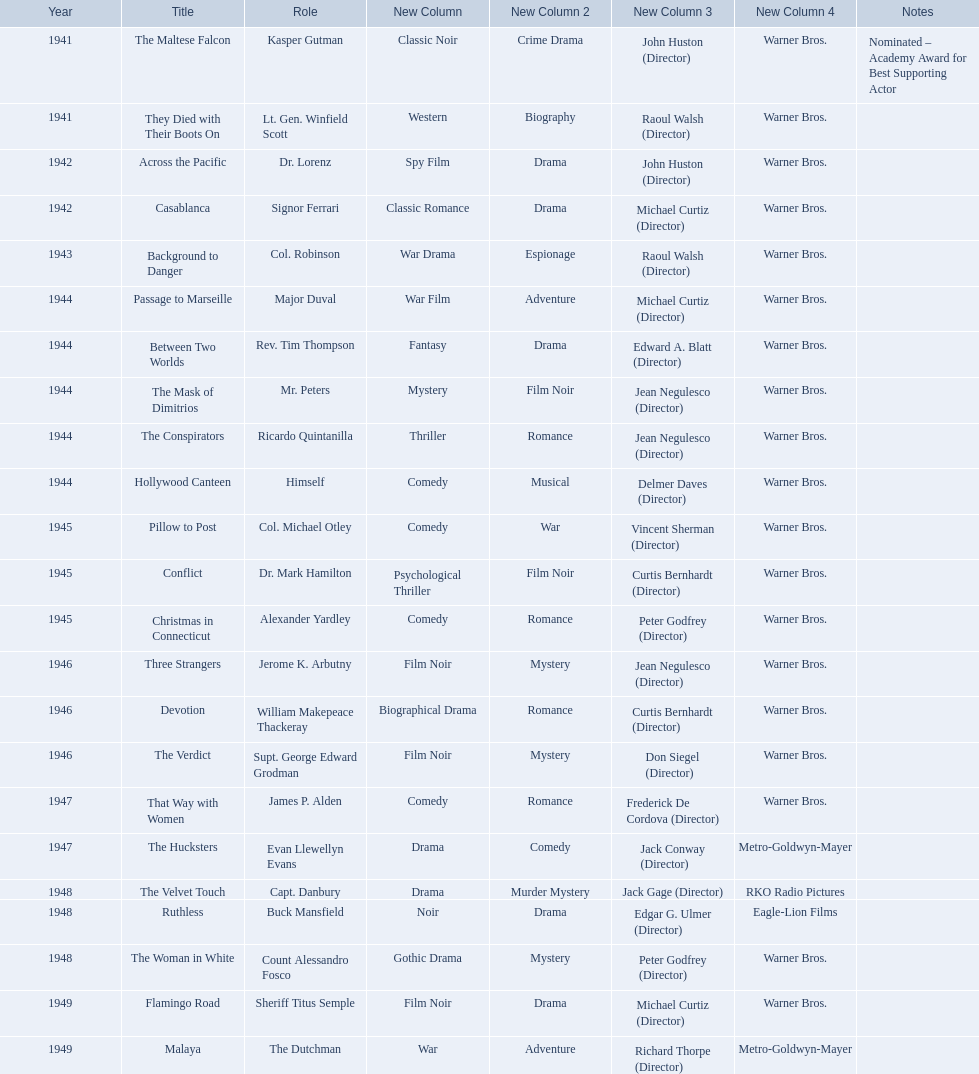What are the movies? The Maltese Falcon, They Died with Their Boots On, Across the Pacific, Casablanca, Background to Danger, Passage to Marseille, Between Two Worlds, The Mask of Dimitrios, The Conspirators, Hollywood Canteen, Pillow to Post, Conflict, Christmas in Connecticut, Three Strangers, Devotion, The Verdict, That Way with Women, The Hucksters, The Velvet Touch, Ruthless, The Woman in White, Flamingo Road, Malaya. Of these, for which did he get nominated for an oscar? The Maltese Falcon. 